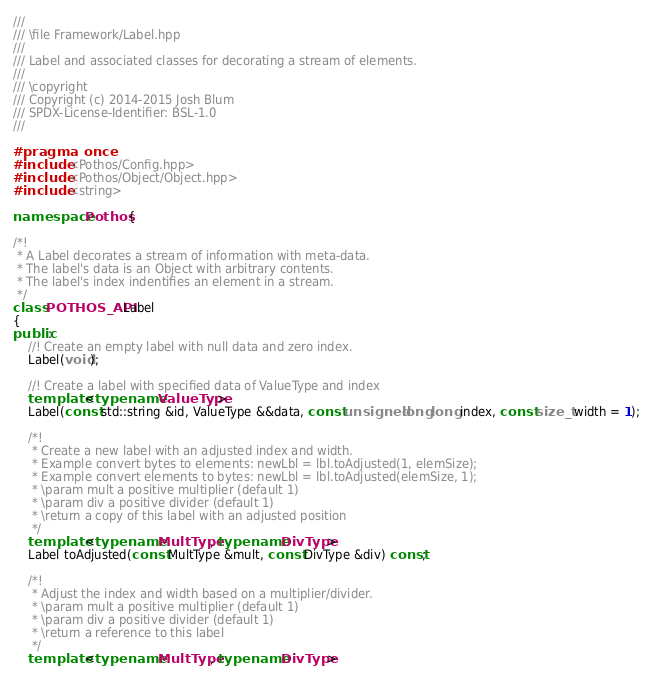Convert code to text. <code><loc_0><loc_0><loc_500><loc_500><_C++_>///
/// \file Framework/Label.hpp
///
/// Label and associated classes for decorating a stream of elements.
///
/// \copyright
/// Copyright (c) 2014-2015 Josh Blum
/// SPDX-License-Identifier: BSL-1.0
///

#pragma once
#include <Pothos/Config.hpp>
#include <Pothos/Object/Object.hpp>
#include <string>

namespace Pothos {

/*!
 * A Label decorates a stream of information with meta-data.
 * The label's data is an Object with arbitrary contents.
 * The label's index indentifies an element in a stream.
 */
class POTHOS_API Label
{
public:
    //! Create an empty label with null data and zero index.
    Label(void);

    //! Create a label with specified data of ValueType and index
    template <typename ValueType>
    Label(const std::string &id, ValueType &&data, const unsigned long long index, const size_t width = 1);

    /*!
     * Create a new label with an adjusted index and width.
     * Example convert bytes to elements: newLbl = lbl.toAdjusted(1, elemSize);
     * Example convert elements to bytes: newLbl = lbl.toAdjusted(elemSize, 1);
     * \param mult a positive multiplier (default 1)
     * \param div a positive divider (default 1)
     * \return a copy of this label with an adjusted position
     */
    template <typename MultType, typename DivType>
    Label toAdjusted(const MultType &mult, const DivType &div) const;

    /*!
     * Adjust the index and width based on a multiplier/divider.
     * \param mult a positive multiplier (default 1)
     * \param div a positive divider (default 1)
     * \return a reference to this label
     */
    template <typename MultType, typename DivType></code> 